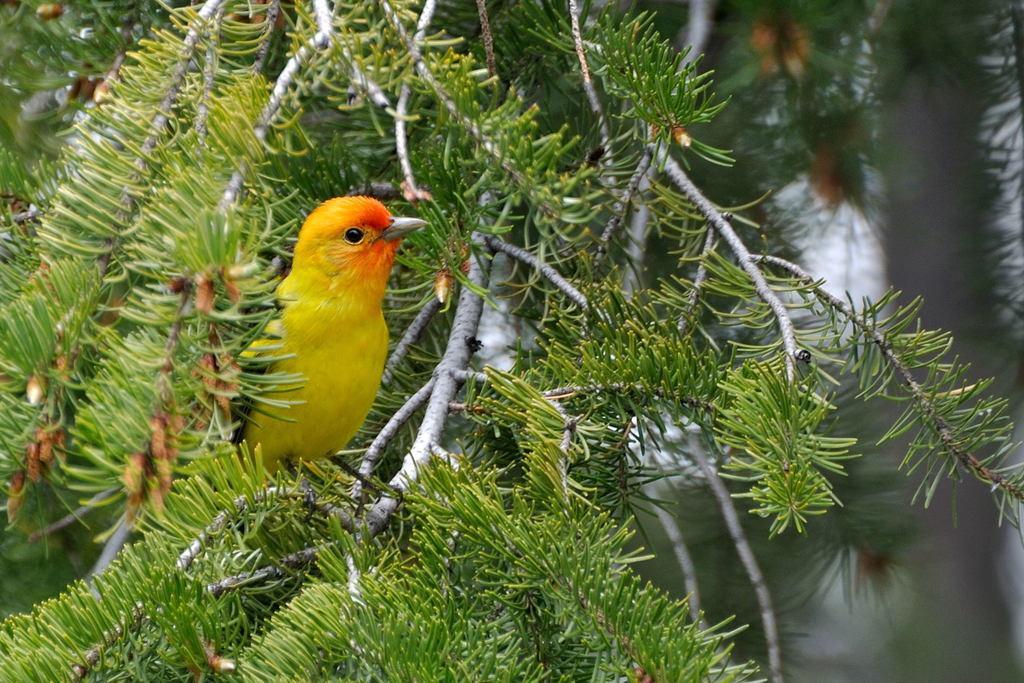Can you describe this image briefly? In this picture I can see a bird on the tree branch and I can see leaves and looks like water in the back. 